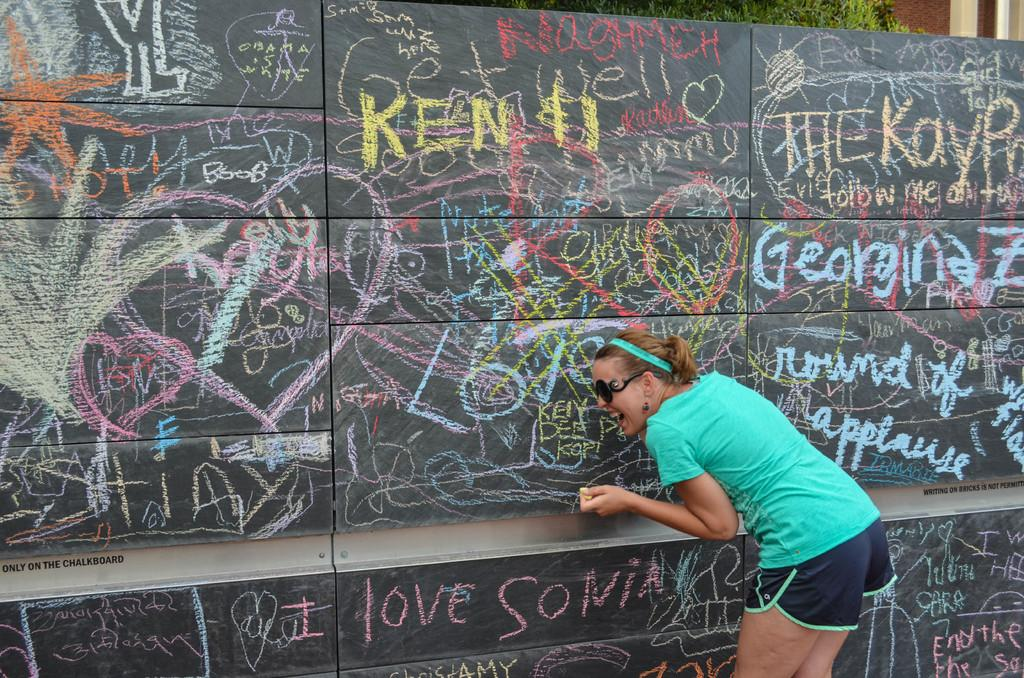Who is present in the image? There is a woman in the image. What is the woman wearing? The woman is wearing a green t-shirt and black shorts. What is the woman doing in the image? The woman is scrubbing on a blackboard. What can be seen in the background of the image? There is a tree and a brown wall visible in the background. What type of crack can be seen on the rifle in the image? There is no rifle present in the image, and therefore no crack can be observed. What is the woman writing on the blackboard in the image? The provided facts do not mention any writing on the blackboard, so we cannot determine what the woman is writing. 